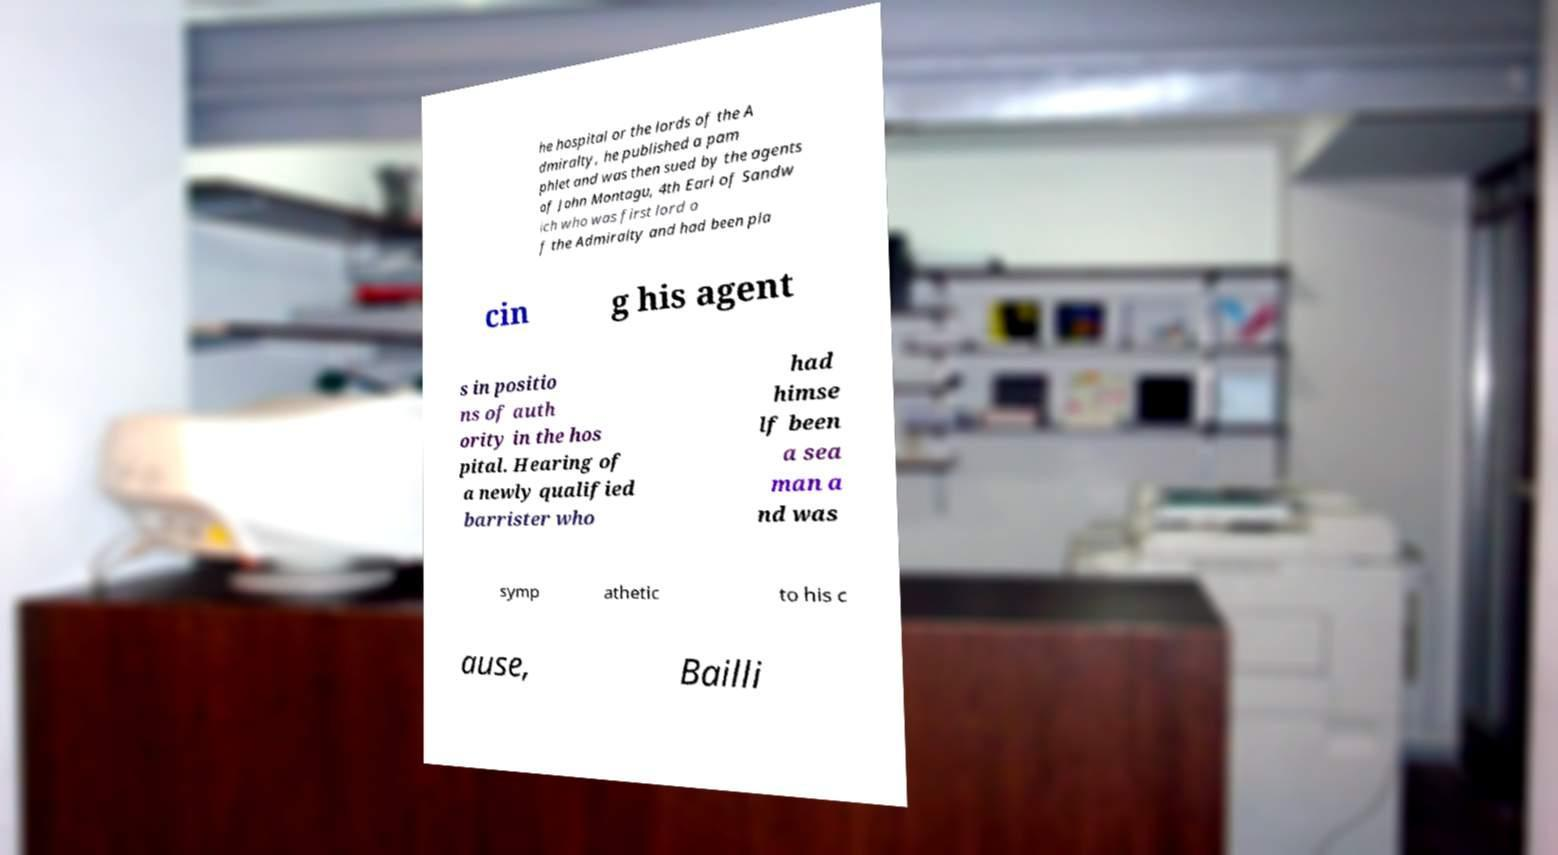For documentation purposes, I need the text within this image transcribed. Could you provide that? he hospital or the lords of the A dmiralty, he published a pam phlet and was then sued by the agents of John Montagu, 4th Earl of Sandw ich who was first lord o f the Admiralty and had been pla cin g his agent s in positio ns of auth ority in the hos pital. Hearing of a newly qualified barrister who had himse lf been a sea man a nd was symp athetic to his c ause, Bailli 